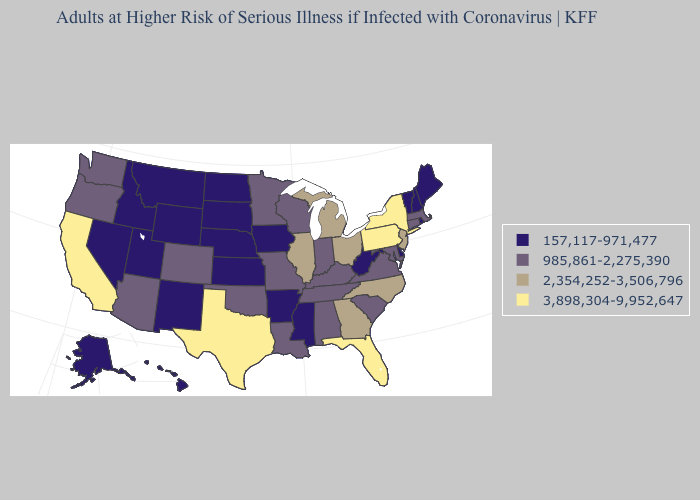What is the value of Virginia?
Give a very brief answer. 985,861-2,275,390. What is the highest value in the West ?
Answer briefly. 3,898,304-9,952,647. What is the lowest value in the USA?
Short answer required. 157,117-971,477. Does Vermont have the lowest value in the Northeast?
Give a very brief answer. Yes. What is the value of Florida?
Concise answer only. 3,898,304-9,952,647. Does Pennsylvania have the same value as California?
Answer briefly. Yes. Which states have the highest value in the USA?
Write a very short answer. California, Florida, New York, Pennsylvania, Texas. What is the lowest value in the USA?
Concise answer only. 157,117-971,477. What is the highest value in the USA?
Concise answer only. 3,898,304-9,952,647. What is the value of North Dakota?
Write a very short answer. 157,117-971,477. What is the value of Iowa?
Write a very short answer. 157,117-971,477. Which states hav the highest value in the West?
Write a very short answer. California. What is the value of South Dakota?
Answer briefly. 157,117-971,477. Among the states that border North Dakota , does Montana have the highest value?
Be succinct. No. Does the map have missing data?
Be succinct. No. 